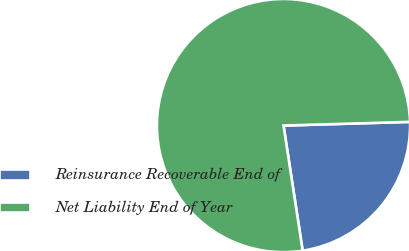Convert chart. <chart><loc_0><loc_0><loc_500><loc_500><pie_chart><fcel>Reinsurance Recoverable End of<fcel>Net Liability End of Year<nl><fcel>23.05%<fcel>76.95%<nl></chart> 